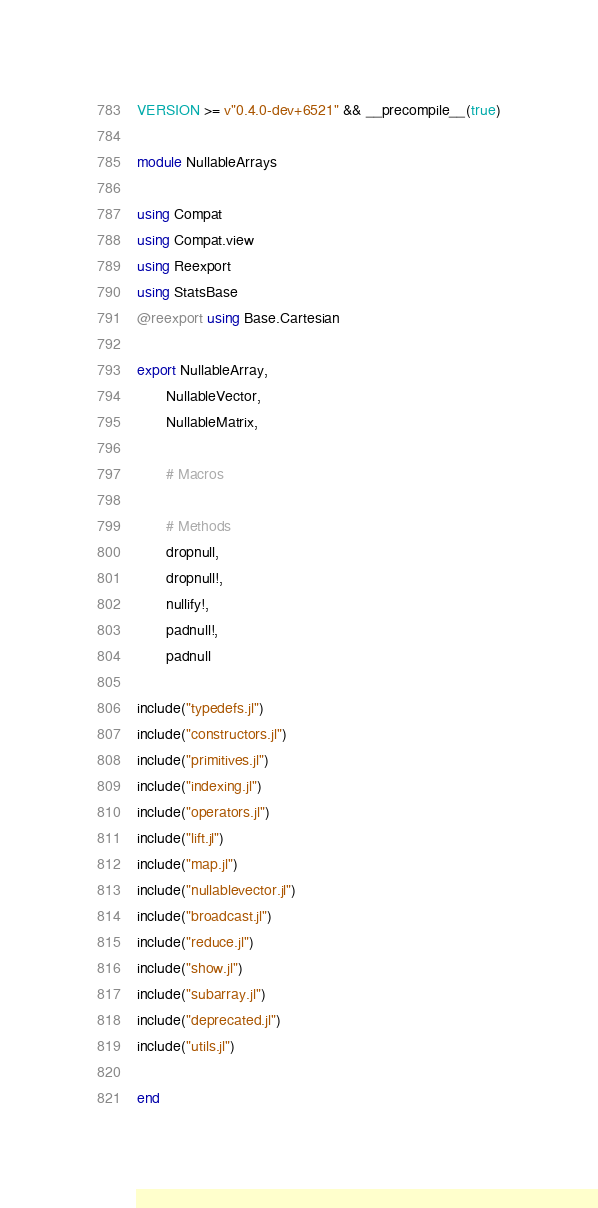<code> <loc_0><loc_0><loc_500><loc_500><_Julia_>VERSION >= v"0.4.0-dev+6521" && __precompile__(true)

module NullableArrays

using Compat
using Compat.view
using Reexport
using StatsBase
@reexport using Base.Cartesian

export NullableArray,
       NullableVector,
       NullableMatrix,

       # Macros

       # Methods
       dropnull,
       dropnull!,
       nullify!,
       padnull!,
       padnull

include("typedefs.jl")
include("constructors.jl")
include("primitives.jl")
include("indexing.jl")
include("operators.jl")
include("lift.jl")
include("map.jl")
include("nullablevector.jl")
include("broadcast.jl")
include("reduce.jl")
include("show.jl")
include("subarray.jl")
include("deprecated.jl")
include("utils.jl")

end
</code> 